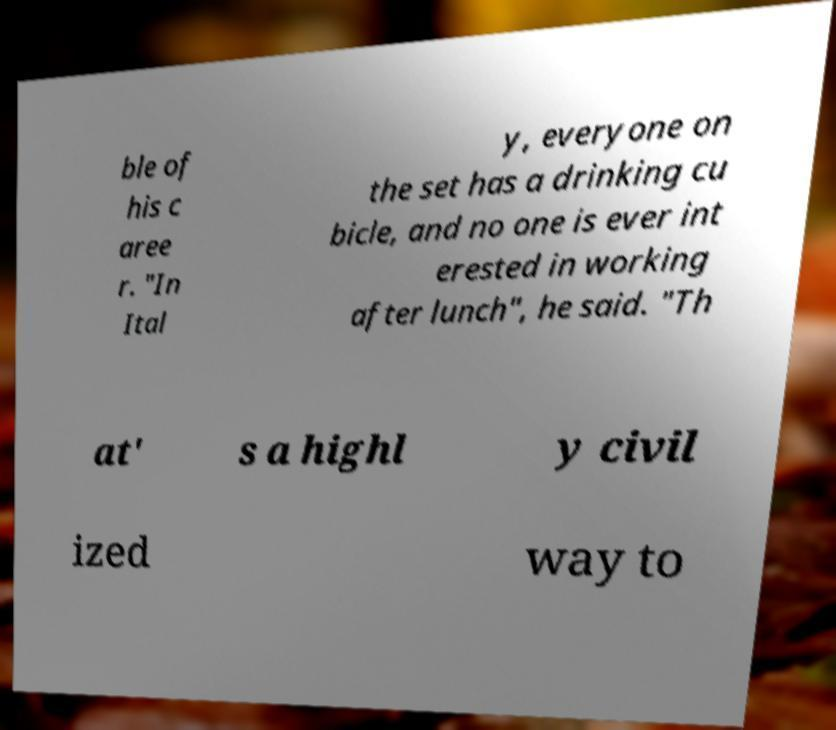Please read and relay the text visible in this image. What does it say? ble of his c aree r. "In Ital y, everyone on the set has a drinking cu bicle, and no one is ever int erested in working after lunch", he said. "Th at' s a highl y civil ized way to 